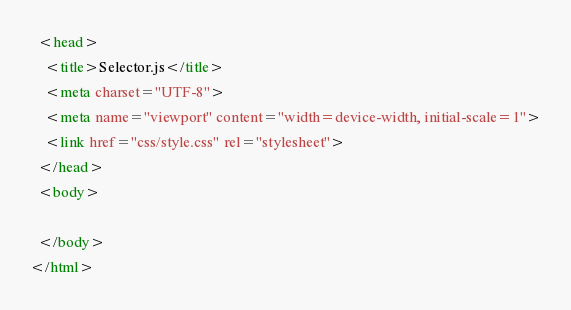Convert code to text. <code><loc_0><loc_0><loc_500><loc_500><_HTML_>  <head>
    <title>Selector.js</title>
    <meta charset="UTF-8">
    <meta name="viewport" content="width=device-width, initial-scale=1">
    <link href="css/style.css" rel="stylesheet">
  </head>
  <body>
  
  </body>
</html></code> 